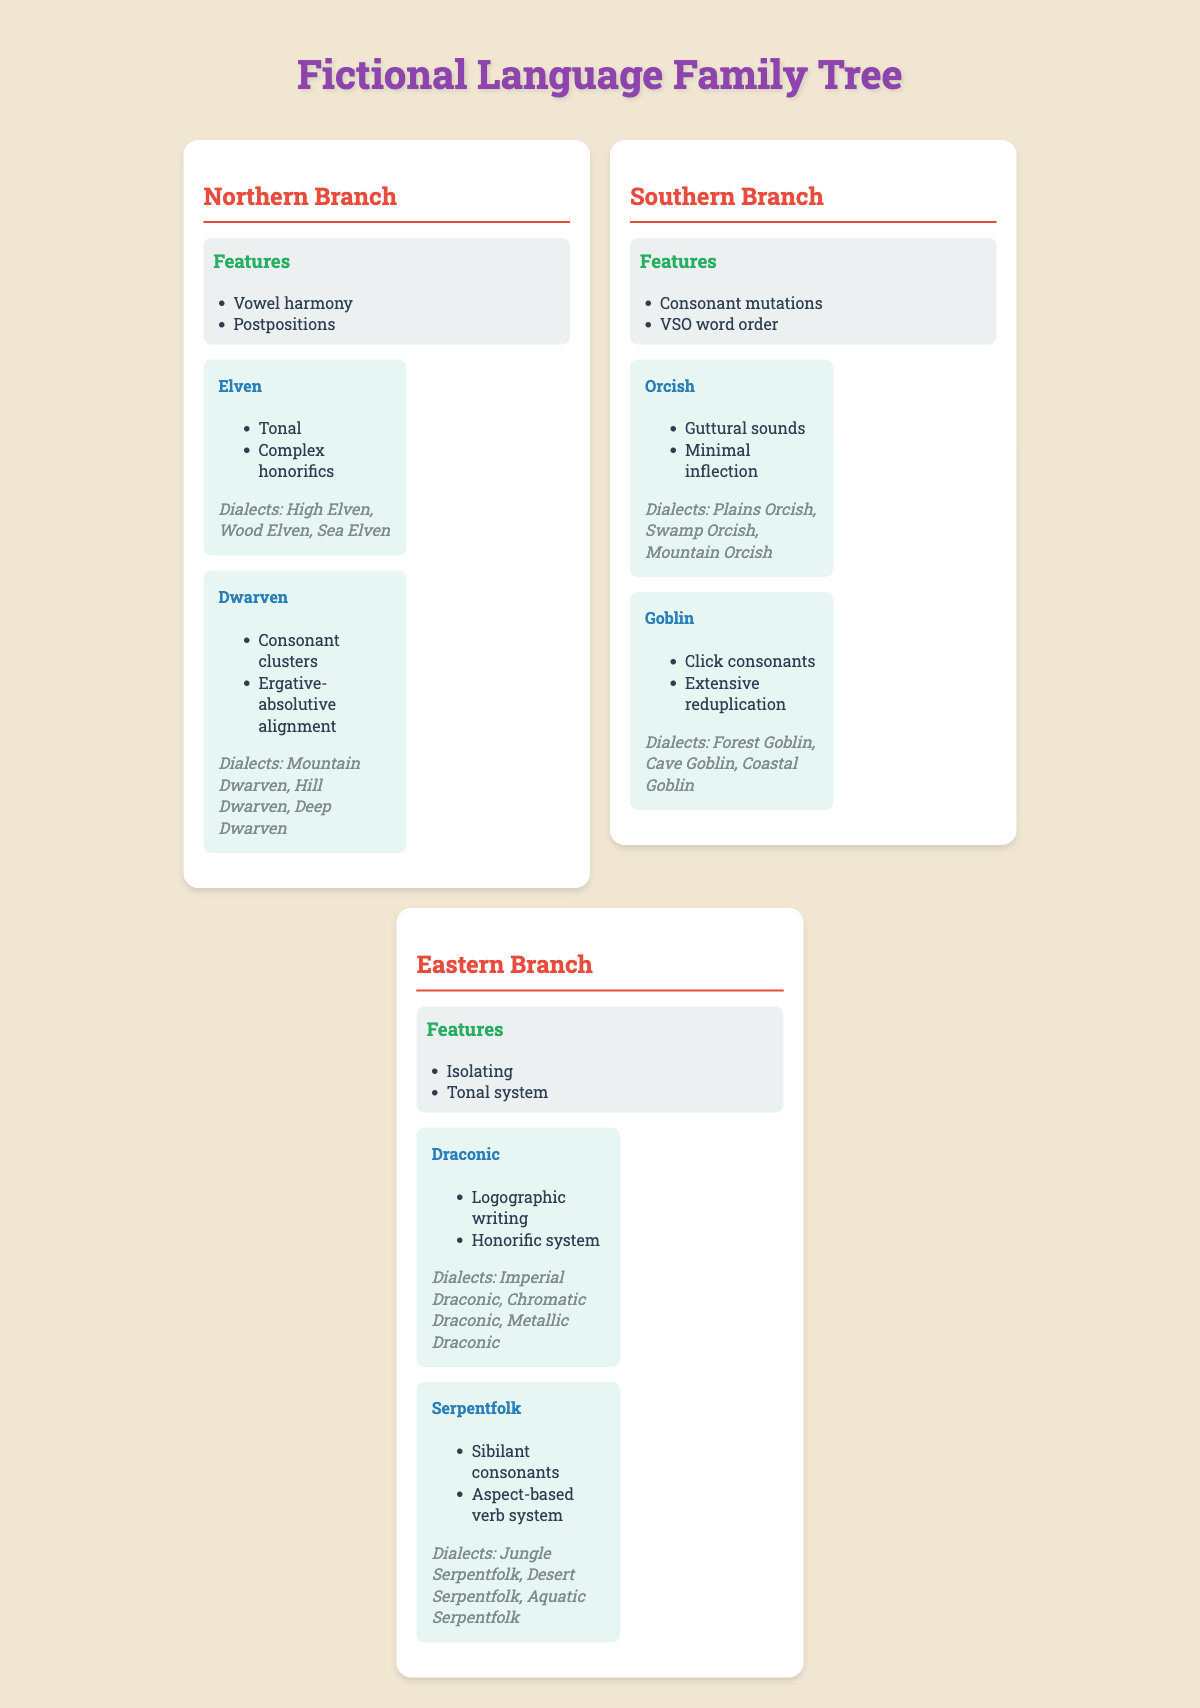What are the features of the Ancient Proto-Language? The features listed under the Ancient Proto-Language section are agglutinative, SOV word order, and extensive case system.
Answer: Agglutinative, SOV word order, extensive case system Which branch of the language family has VSO word order? The Southern Branch has VSO word order as one of its features.
Answer: Southern Branch How many dialects does Elven have? The Elven language has three dialects: High Elven, Wood Elven, and Sea Elven.
Answer: Three dialects Does Dwarven include any dialects? Yes, Dwarven includes dialects, which are Mountain Dwarven, Hill Dwarven, and Deep Dwarven.
Answer: Yes Which descendant languages have tonal features? The Elven and Draconic languages have tonal features.
Answer: Elven and Draconic What is the common feature of the Eastern Branch languages? The common feature of the Eastern Branch languages is that they both have a tonal system.
Answer: Tonal system Which branch has languages that feature postpositions? The Northern Branch has languages that feature postpositions.
Answer: Northern Branch How many total dialects are listed across all languages? There are a total of 9 dialects across the languages: 3 Elven, 3 Dwarven, 3 Orcish, 3 Goblin, 3 Draconic, and 3 Serpentfolk; summing these gives 3 + 3 + 3 + 3 + 3 + 3 = 18 dialects.
Answer: 18 dialects Does Orcish have a complex honorific system? No, Orcish does not have a complex honorific system; this feature is present in Elven.
Answer: No Which branch has features like consonant mutations and guttural sounds? The Southern Branch has features like consonant mutations and guttural sounds in its descendant languages.
Answer: Southern Branch What is the unique writing system associated with Draconic? The unique writing system associated with Draconic is a logographic writing system.
Answer: Logographic writing system Are any of the dialects of Serpentfolk also found in the Northern Branch? No, there are no dialects of Serpentfolk found in the Northern Branch; Serpentfolk dialects are unique to their language.
Answer: No Which descendant language has an ergative-absolutive alignment feature? The Dwarven language features an ergative-absolutive alignment.
Answer: Dwarven How do the features of languages in the Southern Branch compare to those in the Northern Branch? The Southern Branch has VSO word order and consonant mutations, while the Northern Branch has SOV word order and features like vowel harmony.
Answer: Different features What is the main characteristic of the dialects in the Goblin language? The main characteristic of the Goblin language dialects is the presence of click consonants and extensive reduplication.
Answer: Click consonants and extensive reduplication 